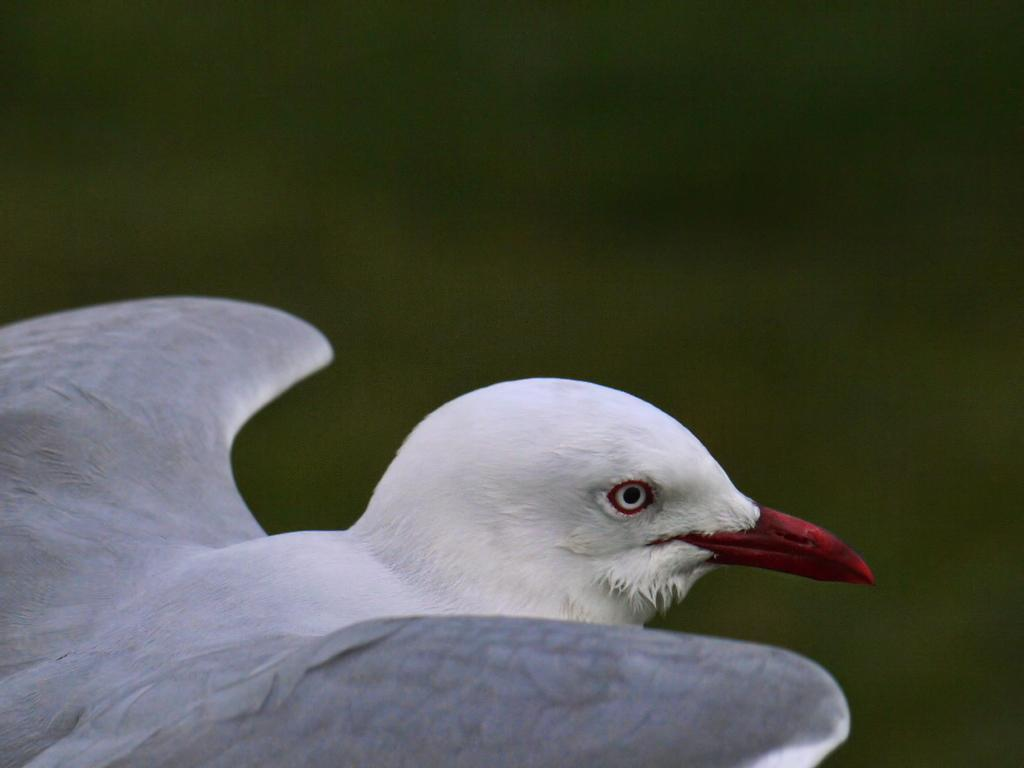What type of animal is in the image? There is a white color bird in the image. In which direction is the bird facing? The bird is facing towards the right side. Can you describe the background of the image? The background of the image is blurred. What type of leather material can be seen in the image? There is no leather material present in the image; it features a white color bird. How many rails are visible in the image? There are no rails present in the image. 